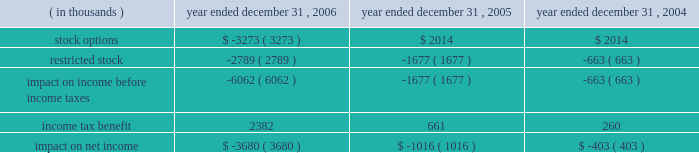Packaging corporation of america notes to consolidated financial statements ( continued ) december 31 , 2006 4 .
Stock-based compensation ( continued ) same period was $ 1988000 lower , than if it had continued to account for share-based compensation under apb no .
25 .
Basic and diluted earnings per share for the year ended december 31 , 2006 were both $ 0.02 lower than if the company had continued to account for share-based compensation under apb no .
25 .
Prior to the adoption of sfas no .
123 ( r ) , the company presented all tax benefits of deductions resulting from share-based payment arrangements as operating cash flows in the statements of cash flows .
Sfas no .
123 ( r ) requires the cash flows resulting from the tax benefits from tax deductions in excess of the compensation cost recognized for those share awards ( excess tax benefits ) to be classified as financing cash flows .
The excess tax benefit of $ 2885000 classified as a financing cash inflow for the year ended december 31 , 2006 would have been classified as an operating cash inflow if the company had not adopted sfas no .
123 ( r ) .
As a result of adopting sfas no 123 ( r ) , unearned compensation previously recorded in stockholders 2019 equity was reclassified against additional paid in capital on january 1 , 2006 .
All stock-based compensation expense not recognized as of december 31 , 2005 and compensation expense related to post 2005 grants of stock options and amortization of restricted stock will be recorded directly to additional paid in capital .
Compensation expense for stock options and restricted stock recognized in the statements of income for the year ended december 31 , 2006 , 2005 and 2004 was as follows : year ended december 31 , ( in thousands ) 2006 2005 2004 .

What was the difference in thousands in impact on net income due to compensation expense for stock options and restricted stock between 2005 and 2006? 
Computations: (3680 - 1016)
Answer: 2664.0. 